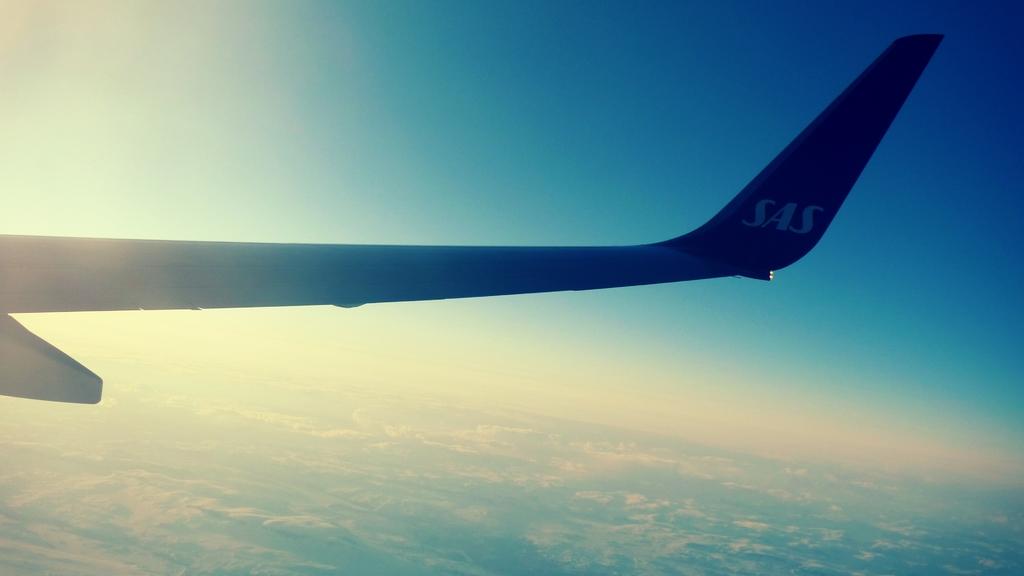What does it say on the aircraft's tail?
Provide a short and direct response. Sas. 